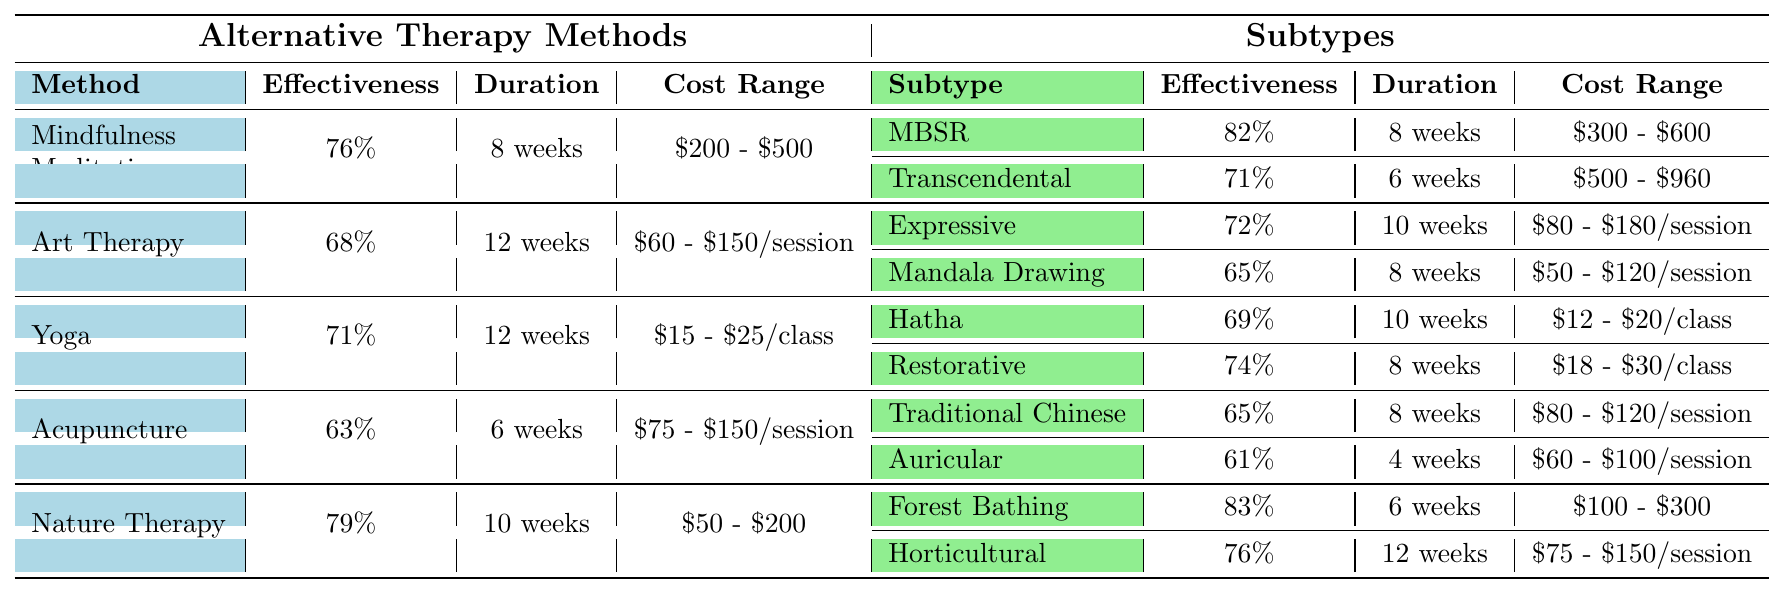What is the effectiveness rate of Nature Therapy? The effectiveness rate of Nature Therapy is listed directly in the table under the Method column, which shows it as 79%.
Answer: 79% How long does Mindfulness-Based Stress Reduction (MBSR) therapy usually last? The average duration for Mindfulness-Based Stress Reduction (MBSR) is directly stated in the table as 8 weeks.
Answer: 8 weeks Which therapy method has the highest effectiveness rate? Comparing the effectiveness rates for all methods, Nature Therapy (79%) is found to have the highest effectiveness rate in the list.
Answer: Nature Therapy What is the cost range for Art Therapy sessions? The table lists the cost range for Art Therapy as $60 - $150 per session, which can be directly found in the Cost Range column.
Answer: $60 - $150 per session How much more effective is Forest Bathing than Auricular Acupuncture? Forest Bathing has an effectiveness rate of 83%, while Auricular Acupuncture has 61%. Therefore, the difference in effectiveness is 83% - 61% = 22%.
Answer: 22% Which subtype of Yoga has a lower effectiveness rate, Hatha Yoga or Restorative Yoga? Hatha Yoga has an effectiveness rate of 69% and Restorative Yoga has a rate of 74%. This means Hatha Yoga is lower than Restorative Yoga.
Answer: Hatha Yoga What is the average duration for all therapy methods listed in the table? The average duration can be calculated by first summing the durations: (8 + 12 + 12 + 6 + 10) weeks = 48 weeks. Then, dividing by the number of methods (5): 48 weeks / 5 = 9.6 weeks.
Answer: 9.6 weeks Is the average cost of Yoga classes higher than that of Art Therapy per session? Yoga has a cost range of $15 - $25 per class, while Art Therapy costs between $60 - $150 per session. Since the minimum cost for Art Therapy is higher than the maximum for Yoga, this statement is true.
Answer: Yes Which subtype of Nature Therapy has the longest duration? Comparing the average durations of the subtypes of Nature Therapy, Forest Bathing lasts 6 weeks and Horticultural Therapy lasts 12 weeks, meaning Horticultural Therapy has the longest duration.
Answer: Horticultural Therapy Overall, what is the average effectiveness rate of all therapy methods listed? The effectiveness rates for all methods sum to (76 + 68 + 71 + 63 + 79) = 417%. Dividing by the number of methods (5): 417% / 5 = 83.4%.
Answer: 83.4% 